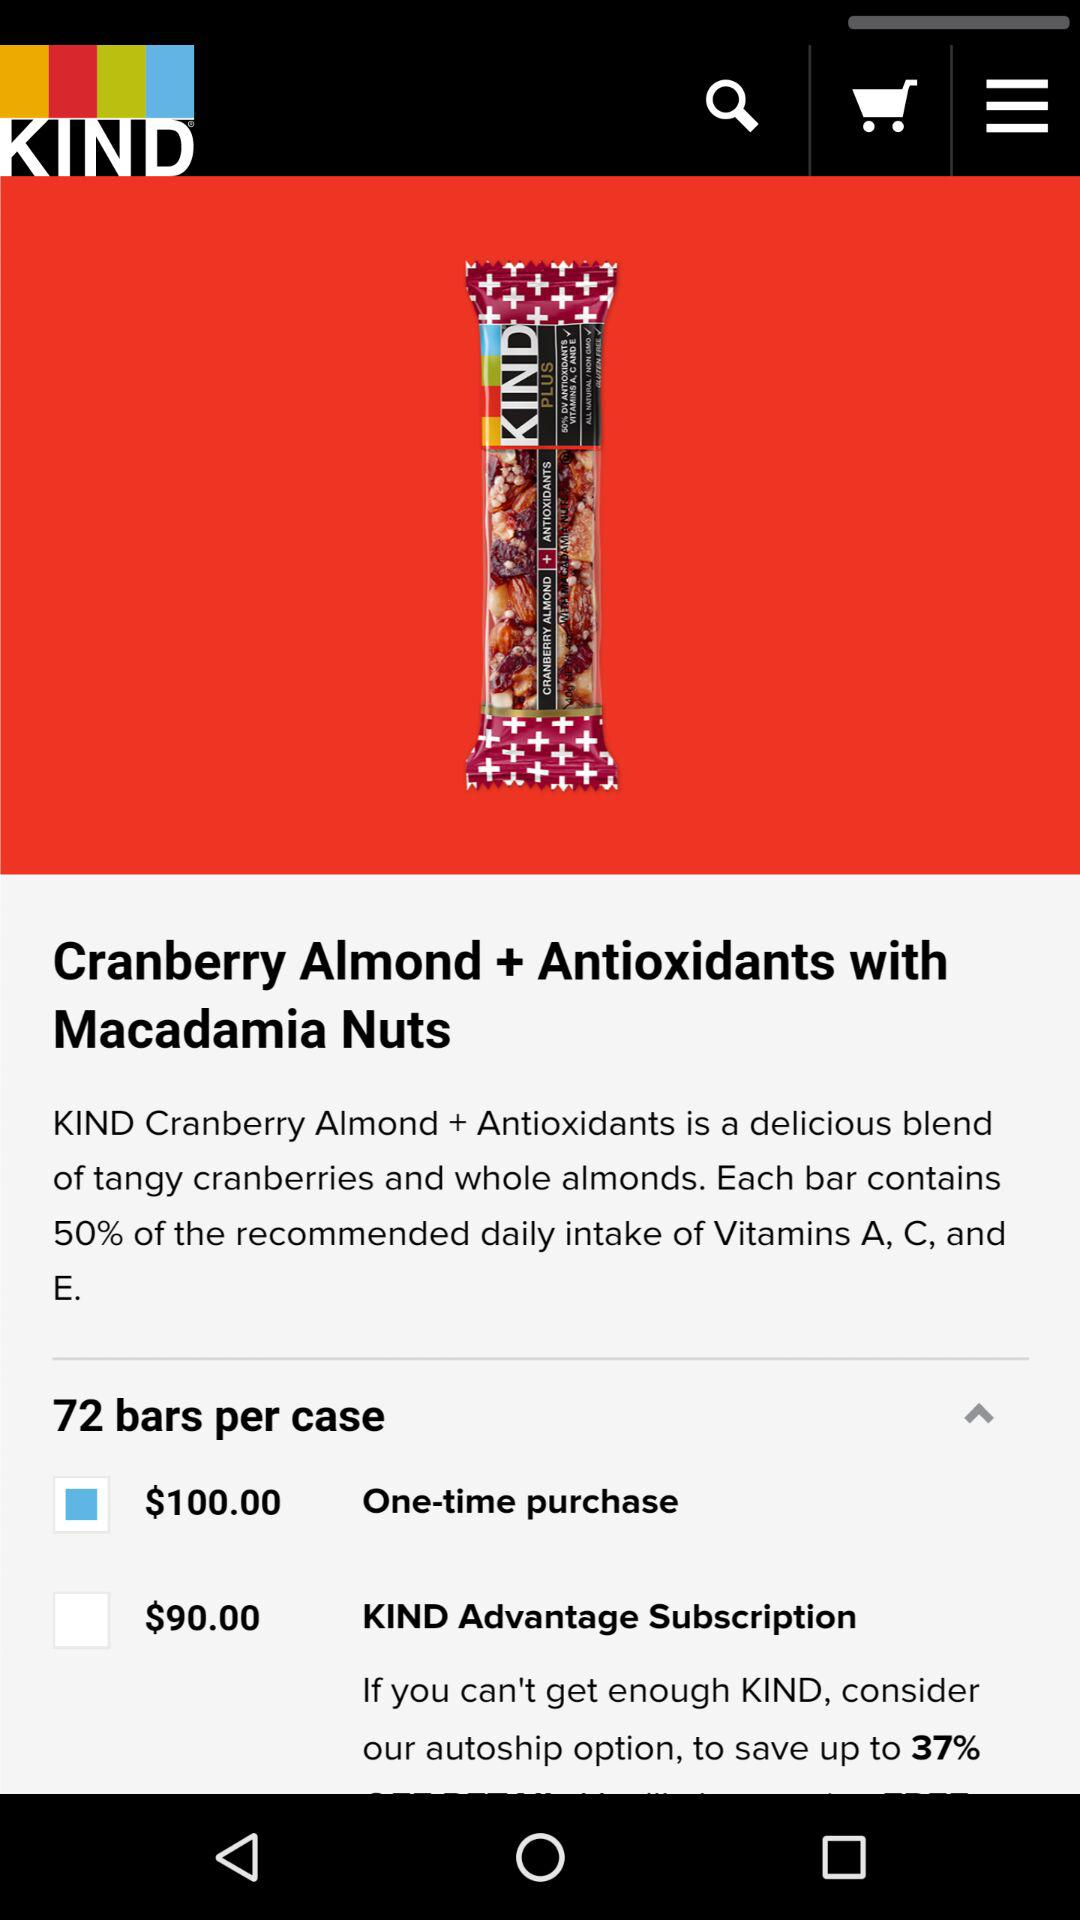What is the price for a one-time purchase? The price is $100. 